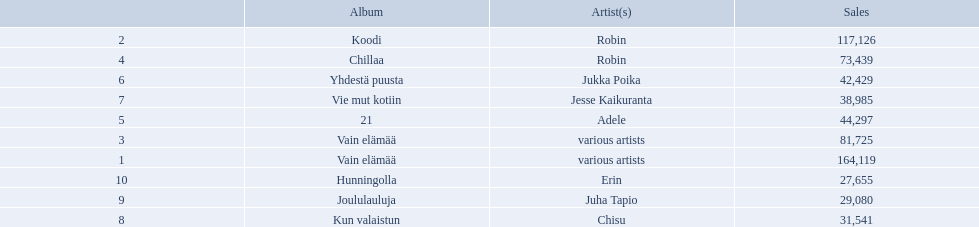Which albums had number-one albums in finland in 2012? 1, Vain elämää, Koodi, Vain elämää, Chillaa, 21, Yhdestä puusta, Vie mut kotiin, Kun valaistun, Joululauluja, Hunningolla. Of those albums, which were recorded by only one artist? Koodi, Chillaa, 21, Yhdestä puusta, Vie mut kotiin, Kun valaistun, Joululauluja, Hunningolla. Which albums made between 30,000 and 45,000 in sales? 21, Yhdestä puusta, Vie mut kotiin, Kun valaistun. Of those albums which had the highest sales? 21. Who was the artist for that album? Adele. 